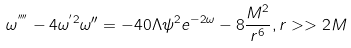Convert formula to latex. <formula><loc_0><loc_0><loc_500><loc_500>\omega ^ { ^ { \prime \prime \prime \prime } } - 4 \omega ^ { ^ { \prime } 2 } \omega { ^ { \prime \prime } } = - 4 0 \Lambda \psi ^ { 2 } e ^ { - 2 \omega } - 8 \frac { M ^ { 2 } } { r ^ { 6 } } , r > > 2 M</formula> 